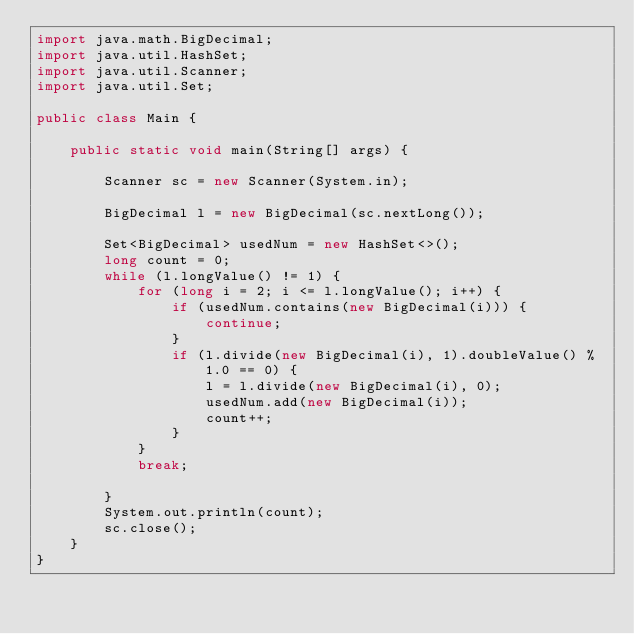Convert code to text. <code><loc_0><loc_0><loc_500><loc_500><_Java_>import java.math.BigDecimal;
import java.util.HashSet;
import java.util.Scanner;
import java.util.Set;

public class Main {

    public static void main(String[] args) {

        Scanner sc = new Scanner(System.in);

        BigDecimal l = new BigDecimal(sc.nextLong());

        Set<BigDecimal> usedNum = new HashSet<>();
        long count = 0;
        while (l.longValue() != 1) {
            for (long i = 2; i <= l.longValue(); i++) {
                if (usedNum.contains(new BigDecimal(i))) {
                    continue;
                }
                if (l.divide(new BigDecimal(i), 1).doubleValue() % 1.0 == 0) {
                    l = l.divide(new BigDecimal(i), 0);
                    usedNum.add(new BigDecimal(i));
                    count++;
                }
            }
            break;

        }
        System.out.println(count);
        sc.close();
    }
}
</code> 